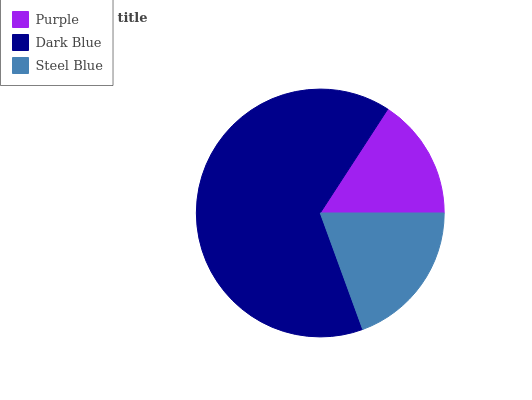Is Purple the minimum?
Answer yes or no. Yes. Is Dark Blue the maximum?
Answer yes or no. Yes. Is Steel Blue the minimum?
Answer yes or no. No. Is Steel Blue the maximum?
Answer yes or no. No. Is Dark Blue greater than Steel Blue?
Answer yes or no. Yes. Is Steel Blue less than Dark Blue?
Answer yes or no. Yes. Is Steel Blue greater than Dark Blue?
Answer yes or no. No. Is Dark Blue less than Steel Blue?
Answer yes or no. No. Is Steel Blue the high median?
Answer yes or no. Yes. Is Steel Blue the low median?
Answer yes or no. Yes. Is Purple the high median?
Answer yes or no. No. Is Purple the low median?
Answer yes or no. No. 